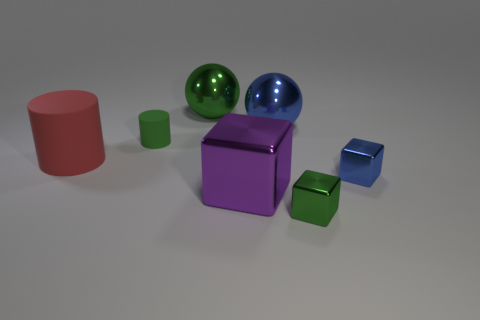Add 3 green objects. How many objects exist? 10 Subtract all purple blocks. How many blocks are left? 2 Subtract 1 cubes. How many cubes are left? 2 Add 7 tiny gray metallic cylinders. How many tiny gray metallic cylinders exist? 7 Subtract 1 purple cubes. How many objects are left? 6 Subtract all cylinders. How many objects are left? 5 Subtract all gray blocks. Subtract all cyan cylinders. How many blocks are left? 3 Subtract all large red cylinders. Subtract all purple balls. How many objects are left? 6 Add 1 green metallic balls. How many green metallic balls are left? 2 